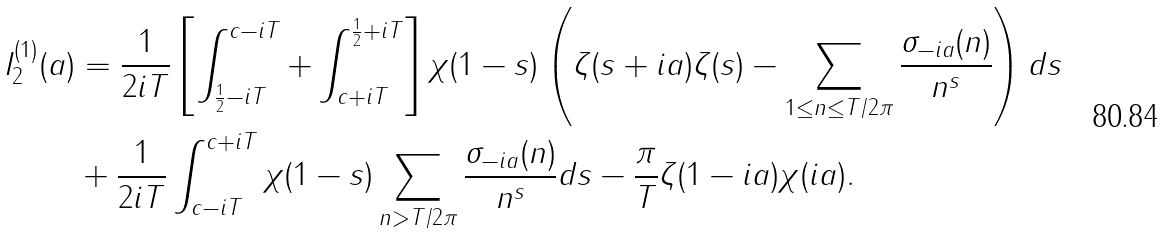Convert formula to latex. <formula><loc_0><loc_0><loc_500><loc_500>I _ { 2 } ^ { ( 1 ) } ( a ) & = \frac { 1 } { 2 i T } \left [ \int _ { \frac { 1 } { 2 } - i T } ^ { c - i T } + \int _ { c + i T } ^ { \frac { 1 } { 2 } + i T } \right ] \chi ( 1 - s ) \left ( \zeta ( s + i a ) \zeta ( s ) - \sum _ { 1 \leq n \leq T / 2 \pi } \frac { \sigma _ { - i a } ( n ) } { n ^ { s } } \right ) d s \\ & + \frac { 1 } { 2 i T } \int _ { c - i T } ^ { c + i T } \chi ( 1 - s ) \sum _ { n > T / 2 \pi } \frac { \sigma _ { - i a } ( n ) } { n ^ { s } } d s - \frac { \pi } { T } \zeta ( 1 - i a ) \chi ( i a ) .</formula> 